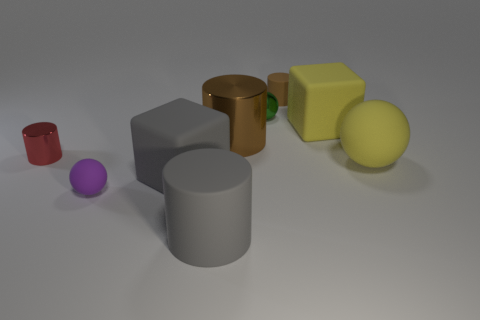Add 1 large purple metallic objects. How many objects exist? 10 Subtract all green cylinders. Subtract all yellow spheres. How many cylinders are left? 4 Subtract all cylinders. How many objects are left? 5 Subtract all large matte cylinders. Subtract all metallic cylinders. How many objects are left? 6 Add 5 small purple rubber things. How many small purple rubber things are left? 6 Add 4 brown shiny objects. How many brown shiny objects exist? 5 Subtract 1 gray cylinders. How many objects are left? 8 